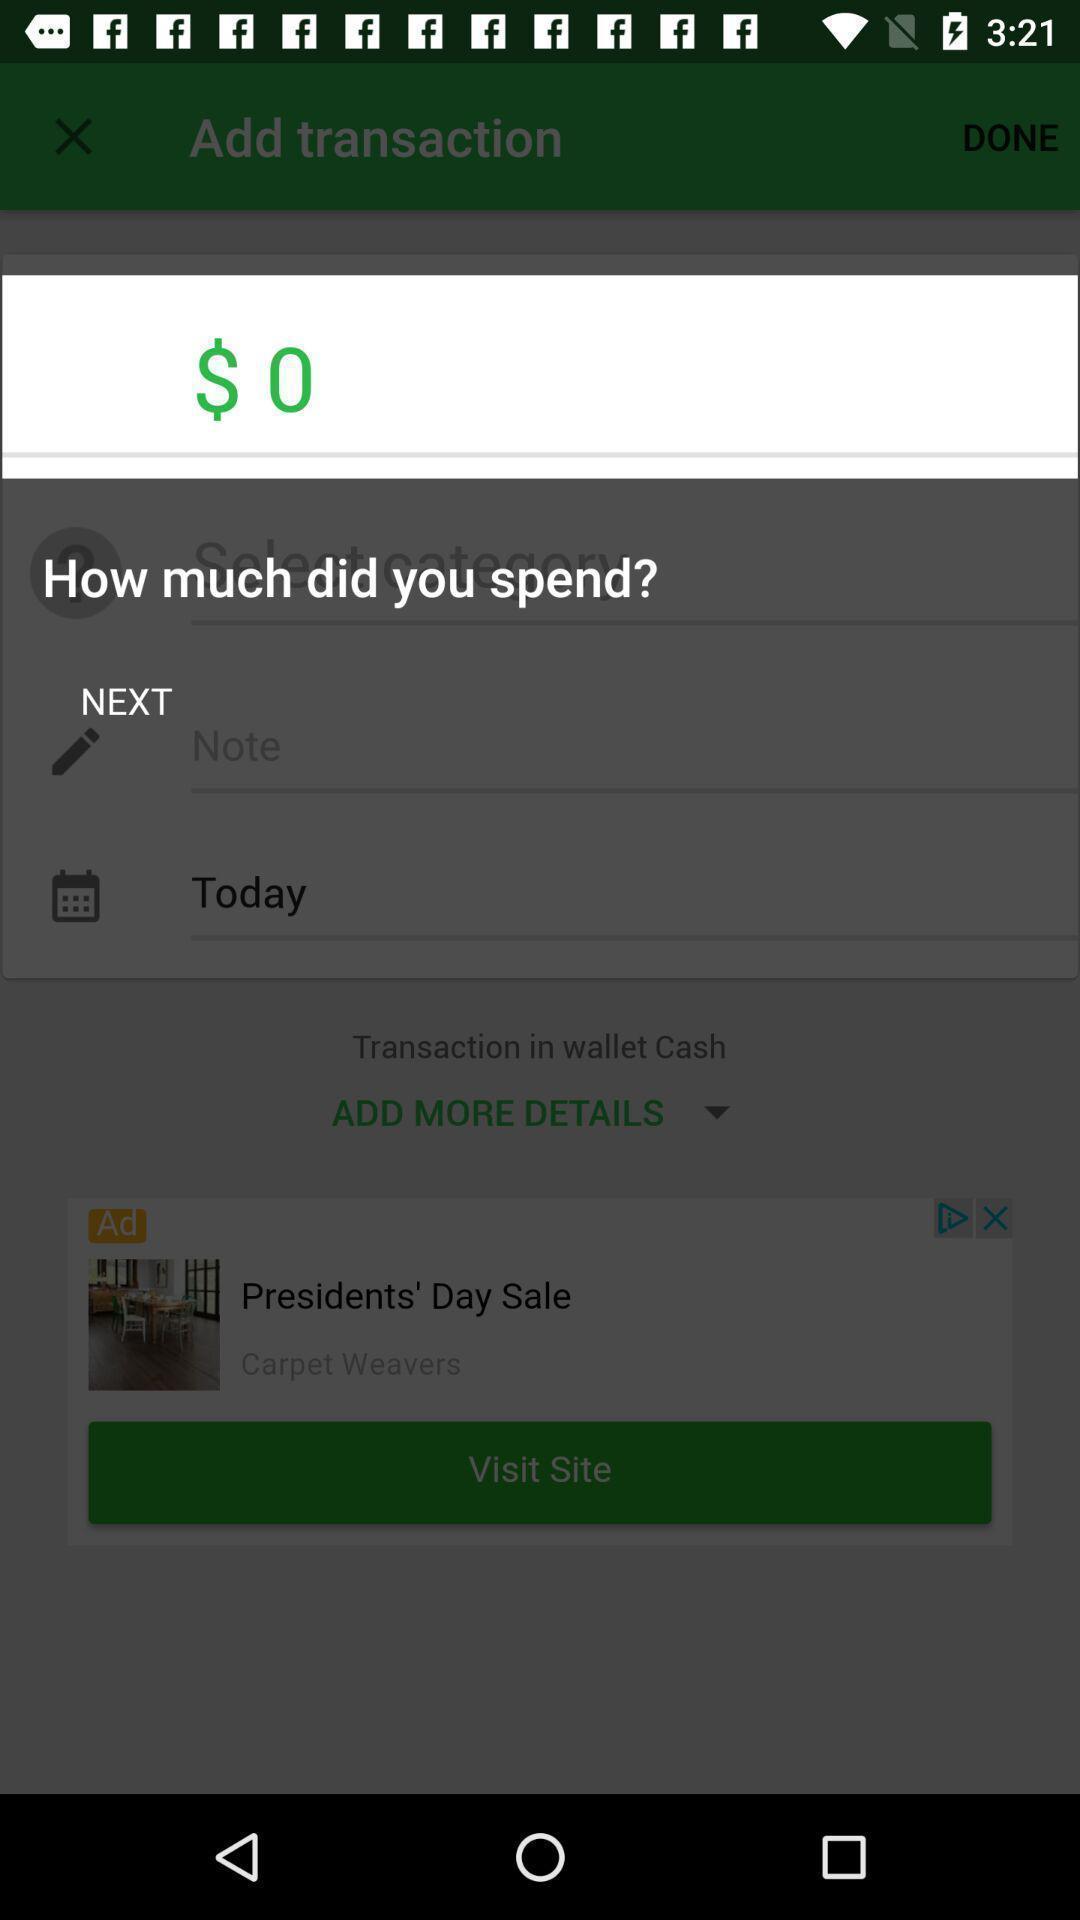Describe the content in this image. Push up message showing spend money in a payment app. 